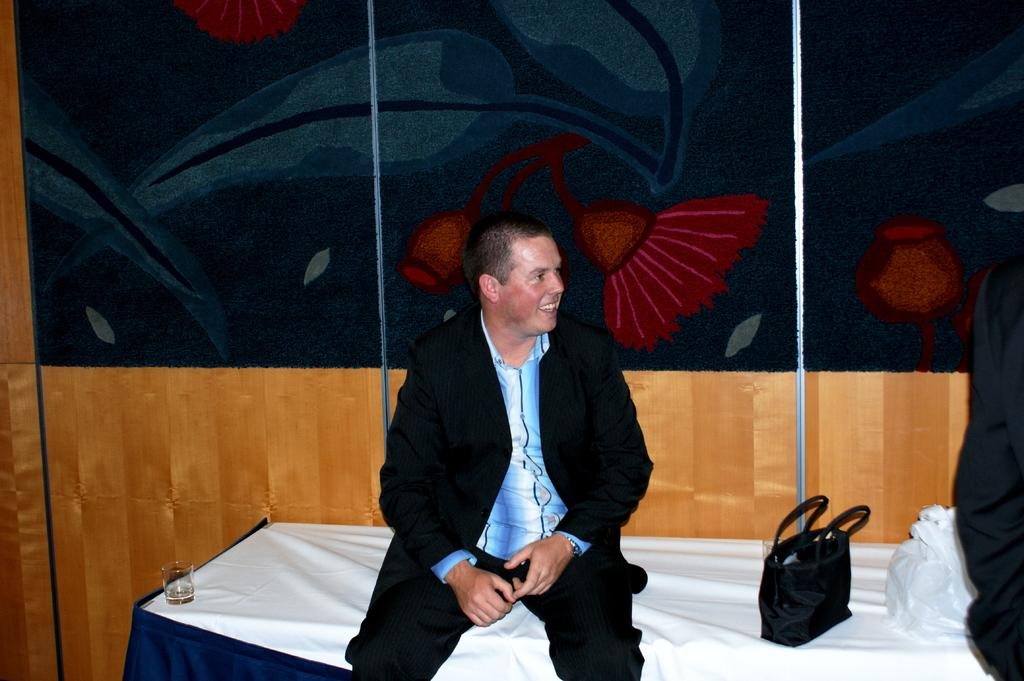What is the person in the image doing? The person is sitting on a bed. What objects are on the bed? There is a glass of wine and a black handbag on the bed. How many people are in the image? There are two people in the image. Can you describe the position of the second person? The second person is standing in the right corner of the image. What type of pen is the person holding in the image? There is no pen present in the image. What kind of bun is the person eating in the image? There is no bun present in the image. 